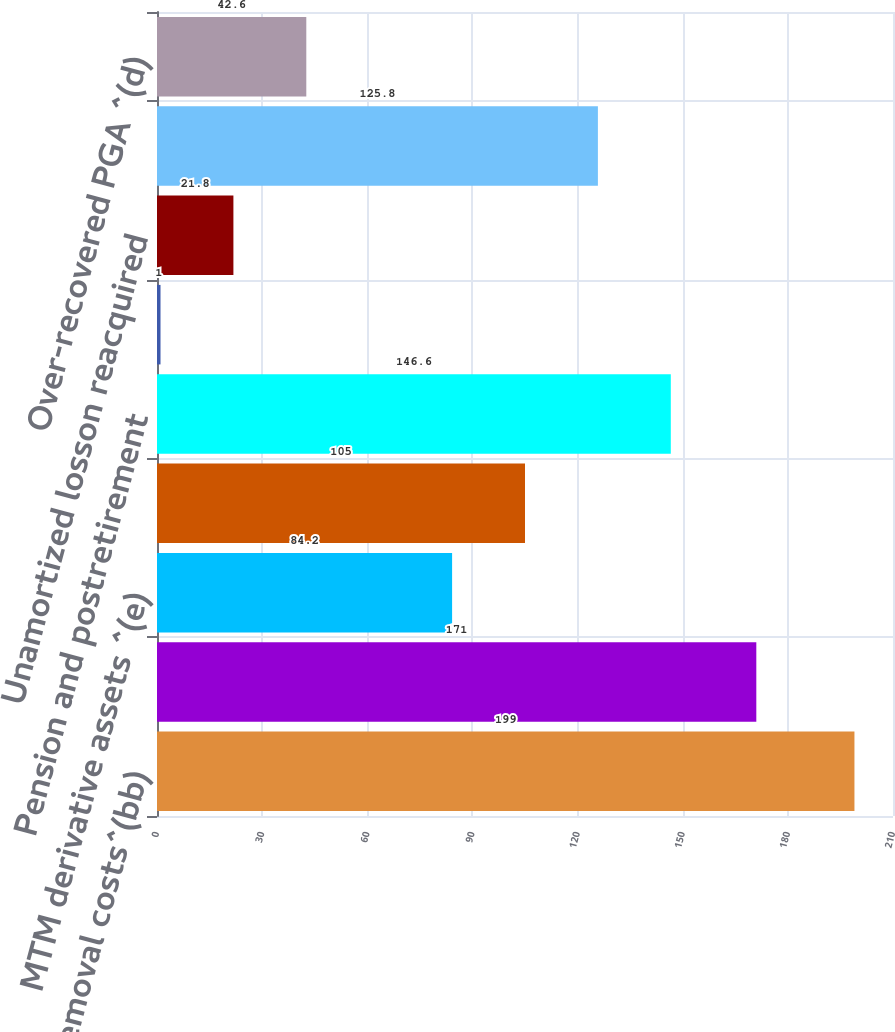Convert chart. <chart><loc_0><loc_0><loc_500><loc_500><bar_chart><fcel>Removal costs^(bb)<fcel>Total noncurrent regulatory<fcel>MTM derivative assets ^(e)<fcel>Total current regulatory<fcel>Pension and postretirement<fcel>Asset retirement obligation<fcel>Unamortized losson reacquired<fcel>MTM derivative assets^(o)<fcel>Over-recovered PGA ^(d)<nl><fcel>199<fcel>171<fcel>84.2<fcel>105<fcel>146.6<fcel>1<fcel>21.8<fcel>125.8<fcel>42.6<nl></chart> 